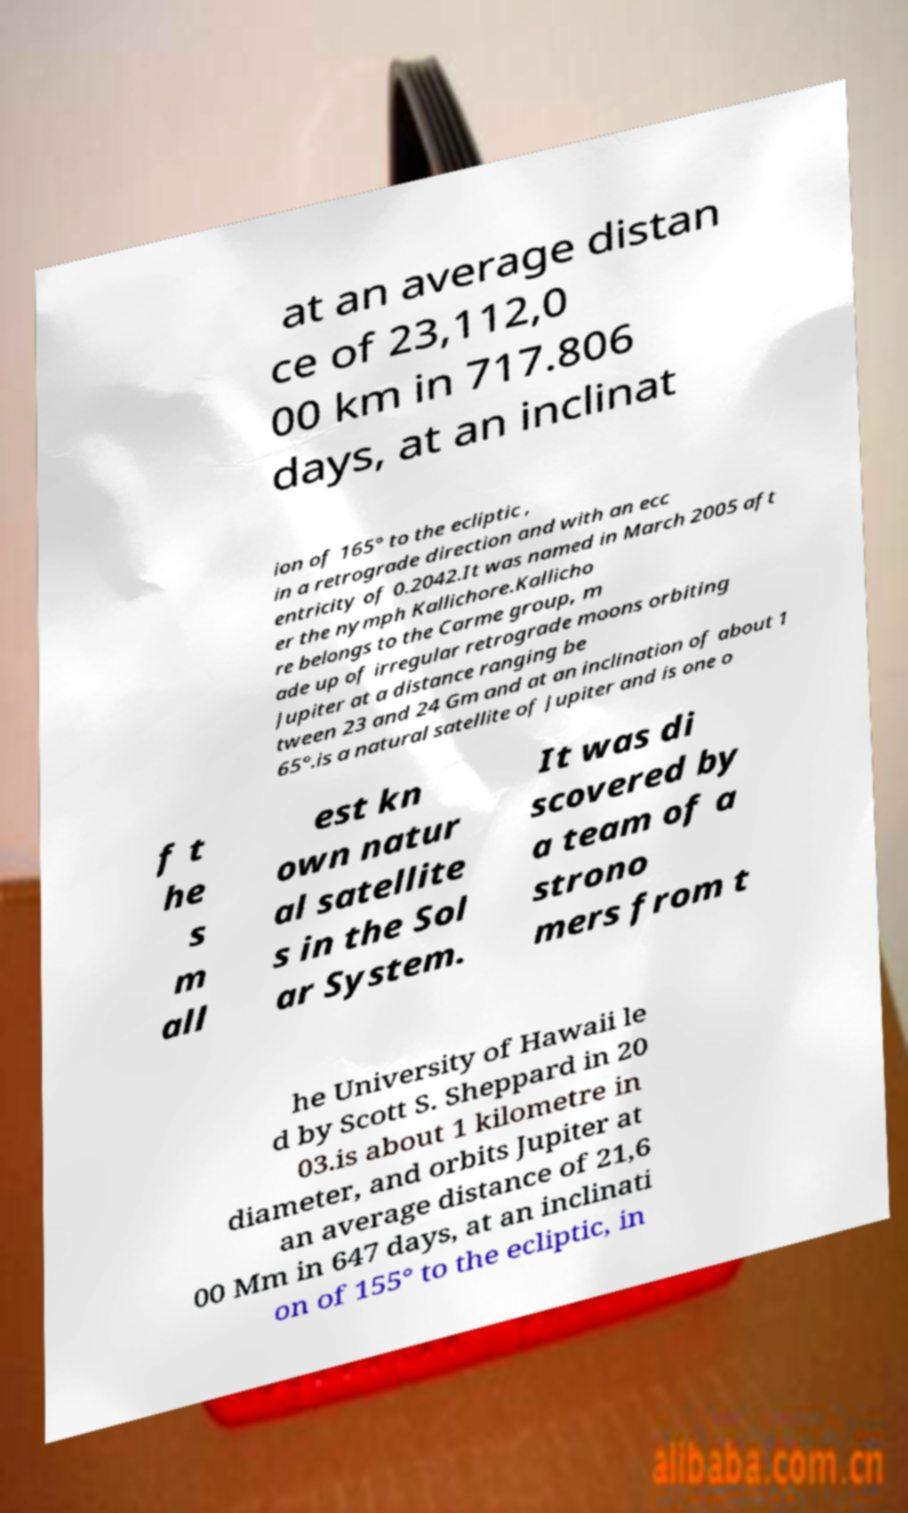Could you extract and type out the text from this image? at an average distan ce of 23,112,0 00 km in 717.806 days, at an inclinat ion of 165° to the ecliptic , in a retrograde direction and with an ecc entricity of 0.2042.It was named in March 2005 aft er the nymph Kallichore.Kallicho re belongs to the Carme group, m ade up of irregular retrograde moons orbiting Jupiter at a distance ranging be tween 23 and 24 Gm and at an inclination of about 1 65°.is a natural satellite of Jupiter and is one o f t he s m all est kn own natur al satellite s in the Sol ar System. It was di scovered by a team of a strono mers from t he University of Hawaii le d by Scott S. Sheppard in 20 03.is about 1 kilometre in diameter, and orbits Jupiter at an average distance of 21,6 00 Mm in 647 days, at an inclinati on of 155° to the ecliptic, in 